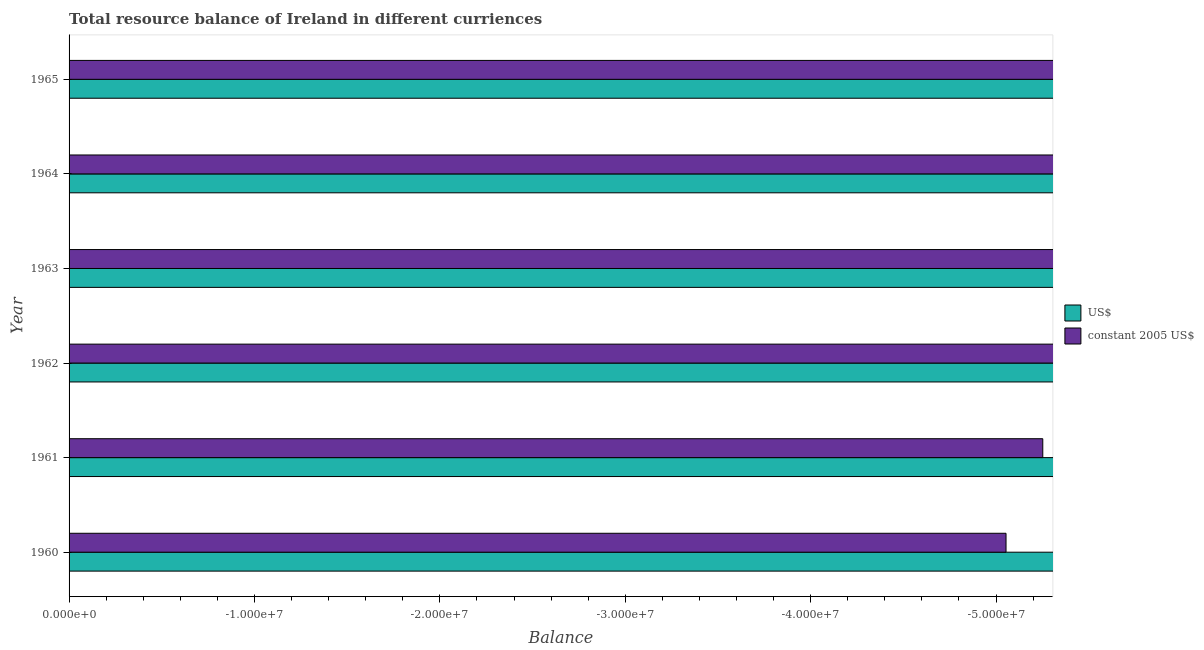Are the number of bars per tick equal to the number of legend labels?
Provide a succinct answer. No. Are the number of bars on each tick of the Y-axis equal?
Provide a succinct answer. Yes. In how many cases, is the number of bars for a given year not equal to the number of legend labels?
Your answer should be very brief. 6. Across all years, what is the minimum resource balance in us$?
Ensure brevity in your answer.  0. What is the total resource balance in constant us$ in the graph?
Ensure brevity in your answer.  0. In how many years, is the resource balance in constant us$ greater than the average resource balance in constant us$ taken over all years?
Offer a terse response. 0. How many bars are there?
Offer a terse response. 0. Are all the bars in the graph horizontal?
Your answer should be very brief. Yes. What is the difference between two consecutive major ticks on the X-axis?
Offer a very short reply. 1.00e+07. How many legend labels are there?
Make the answer very short. 2. What is the title of the graph?
Your answer should be very brief. Total resource balance of Ireland in different curriences. Does "Forest" appear as one of the legend labels in the graph?
Offer a very short reply. No. What is the label or title of the X-axis?
Provide a short and direct response. Balance. What is the label or title of the Y-axis?
Ensure brevity in your answer.  Year. What is the Balance in US$ in 1961?
Offer a terse response. 0. What is the Balance in constant 2005 US$ in 1961?
Your answer should be compact. 0. What is the Balance in US$ in 1962?
Offer a terse response. 0. What is the Balance of constant 2005 US$ in 1962?
Your answer should be very brief. 0. What is the Balance of constant 2005 US$ in 1963?
Your answer should be very brief. 0. What is the Balance in US$ in 1964?
Make the answer very short. 0. What is the Balance of constant 2005 US$ in 1964?
Provide a short and direct response. 0. What is the Balance of constant 2005 US$ in 1965?
Provide a succinct answer. 0. What is the total Balance of US$ in the graph?
Your answer should be compact. 0. What is the average Balance in US$ per year?
Keep it short and to the point. 0. 